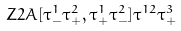<formula> <loc_0><loc_0><loc_500><loc_500>Z 2 A [ \tau ^ { 1 } _ { - } \tau ^ { 2 } _ { + } , \tau ^ { 1 } _ { + } \tau ^ { 2 } _ { - } ] \tau ^ { 1 2 } \tau ^ { 3 } _ { + }</formula> 